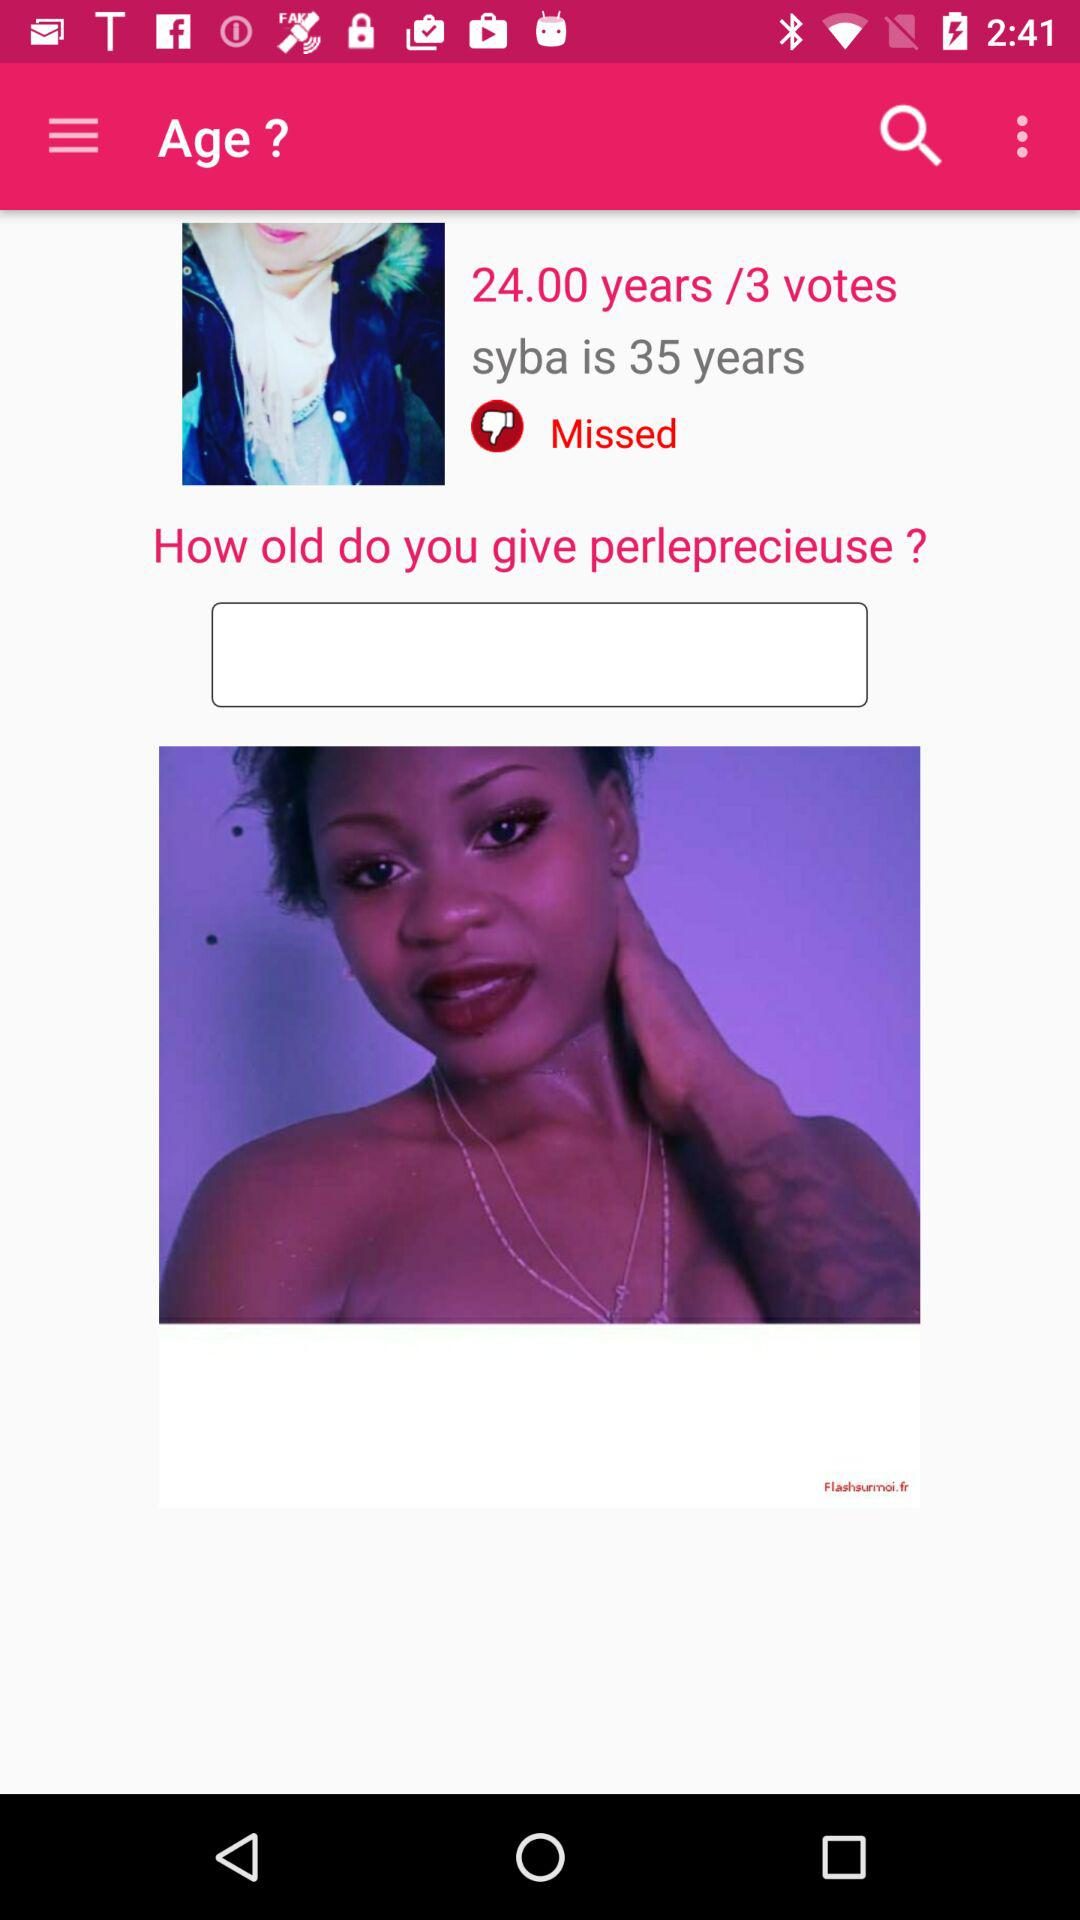What is the age of the person? The age is 35 years old. 